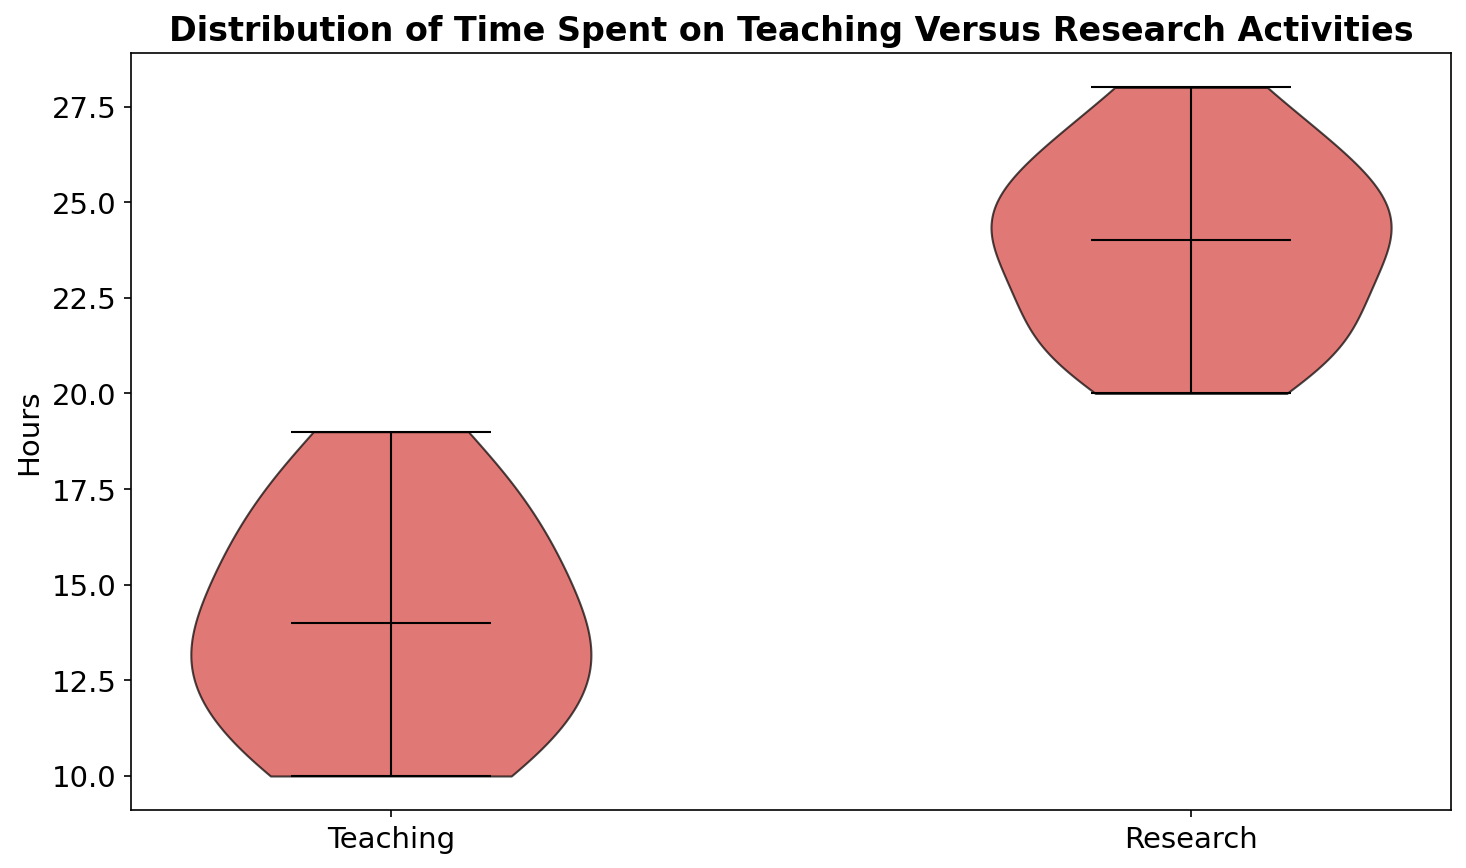What is the median number of hours spent on teaching? The median number of hours spent on teaching is represented by the horizontal line inside the violin plot for the 'Teaching' category. It is visually at 14 hours.
Answer: 14 What is the range of hours spent on research? The range is determined by the difference between the maximum and minimum values within the violin plot for the 'Research' category. The maximum is 28 hours, and the minimum is 20 hours. The range is 28 - 20 = 8 hours.
Answer: 8 Which activity, teaching or research, shows greater variability in hours spent? Variability can be evaluated by looking at the width and spread of the violin plots. The 'Research' category shows a wider spread compared to the 'Teaching'. Thus, research has greater variability.
Answer: Research How do the median teaching hours compare to the median research hours? Comparing the horizontal lines representing the medians of the two violin plots, the median teaching hours are lower than the median research hours. The median for teaching is 14 hours, whereas for research it is 24 hours.
Answer: Teaching hours are lower Is there any overlap in the hours spent on teaching and research? Overlap is seen if the intervals of hours for both categories intersect. The 'Teaching' category ranges from 10 to 19 hours, while the 'Research' category ranges from 20 to 28 hours. There is no overlap in hours spent on the two activities.
Answer: No Which activity has a higher maximum number of hours? By observing the topmost point of each violin plot, the 'Research' category has a higher maximum (28 hours) compared to 'Teaching' (19 hours).
Answer: Research What is the average range of hours in the teaching category? Averaging involves summing the minimum (10), median (14), and maximum (19) values in the 'Teaching' category and then dividing by 3. (10 + 14 + 19) / 3 = 43 / 3 = 14.33
Answer: 14.33 How many hours are more frequently spent on research compared to teaching, according to the plot shapes? By comparing the density and width of the violin plots, the 'Research' category shows a higher concentration of hours around 24-26, whereas 'Teaching' shows more spread. This indicates early career mathematicians frequently spend more hours on research than teaching.
Answer: More on research What does the color red in the plots indicate? The color red in the violin plots is used for both the 'Teaching' and 'Research' categories to indicate the distribution of hours. The same color helps to visually compare the two categories directly.
Answer: Distribution of hours 